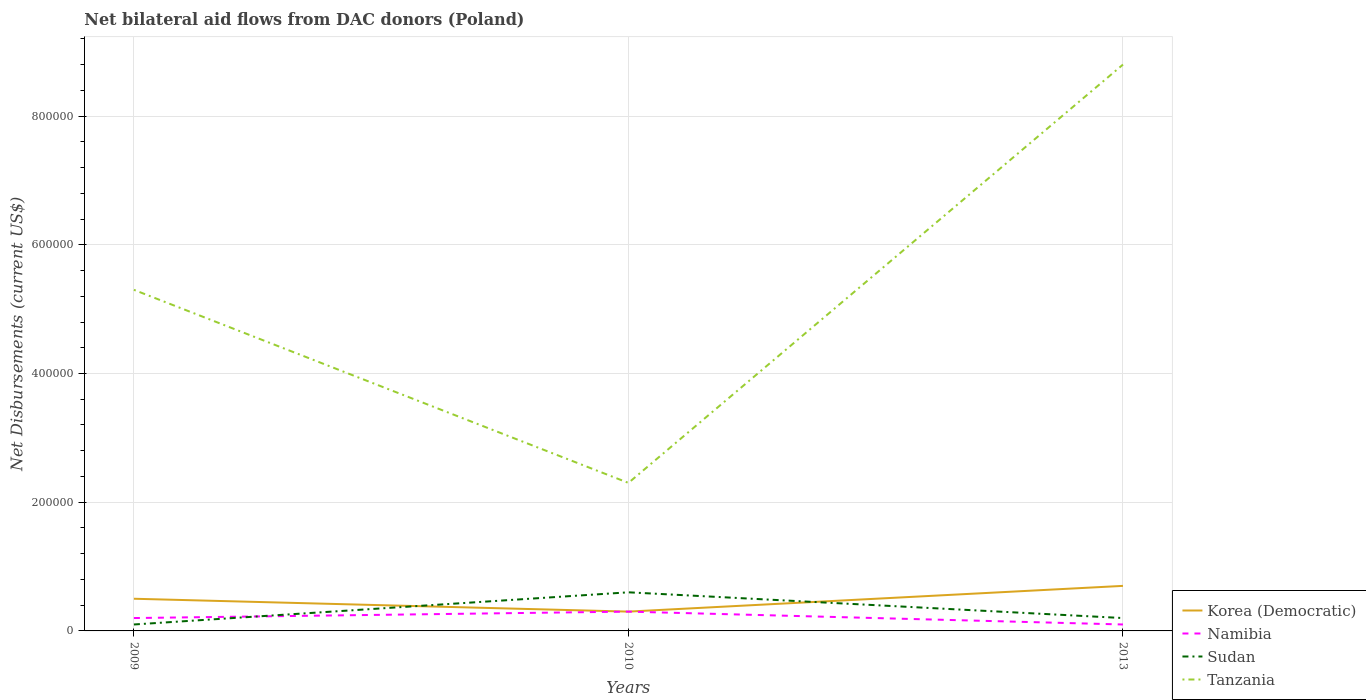Is the number of lines equal to the number of legend labels?
Offer a very short reply. Yes. Across all years, what is the maximum net bilateral aid flows in Korea (Democratic)?
Ensure brevity in your answer.  3.00e+04. What is the total net bilateral aid flows in Korea (Democratic) in the graph?
Offer a very short reply. 2.00e+04. What is the difference between the highest and the second highest net bilateral aid flows in Tanzania?
Your answer should be compact. 6.50e+05. What is the difference between the highest and the lowest net bilateral aid flows in Sudan?
Ensure brevity in your answer.  1. Is the net bilateral aid flows in Korea (Democratic) strictly greater than the net bilateral aid flows in Sudan over the years?
Make the answer very short. No. How many lines are there?
Provide a succinct answer. 4. How many years are there in the graph?
Your answer should be very brief. 3. Does the graph contain grids?
Your answer should be very brief. Yes. How many legend labels are there?
Offer a terse response. 4. What is the title of the graph?
Ensure brevity in your answer.  Net bilateral aid flows from DAC donors (Poland). What is the label or title of the Y-axis?
Ensure brevity in your answer.  Net Disbursements (current US$). What is the Net Disbursements (current US$) of Namibia in 2009?
Ensure brevity in your answer.  2.00e+04. What is the Net Disbursements (current US$) in Tanzania in 2009?
Offer a terse response. 5.30e+05. What is the Net Disbursements (current US$) of Korea (Democratic) in 2010?
Give a very brief answer. 3.00e+04. What is the Net Disbursements (current US$) in Namibia in 2010?
Your response must be concise. 3.00e+04. What is the Net Disbursements (current US$) in Tanzania in 2010?
Provide a short and direct response. 2.30e+05. What is the Net Disbursements (current US$) in Korea (Democratic) in 2013?
Your answer should be compact. 7.00e+04. What is the Net Disbursements (current US$) in Tanzania in 2013?
Provide a short and direct response. 8.80e+05. Across all years, what is the maximum Net Disbursements (current US$) of Korea (Democratic)?
Give a very brief answer. 7.00e+04. Across all years, what is the maximum Net Disbursements (current US$) in Tanzania?
Your answer should be compact. 8.80e+05. Across all years, what is the minimum Net Disbursements (current US$) in Namibia?
Your answer should be very brief. 10000. Across all years, what is the minimum Net Disbursements (current US$) of Tanzania?
Offer a terse response. 2.30e+05. What is the total Net Disbursements (current US$) in Namibia in the graph?
Offer a very short reply. 6.00e+04. What is the total Net Disbursements (current US$) in Sudan in the graph?
Offer a very short reply. 9.00e+04. What is the total Net Disbursements (current US$) in Tanzania in the graph?
Your answer should be compact. 1.64e+06. What is the difference between the Net Disbursements (current US$) of Korea (Democratic) in 2009 and that in 2010?
Your answer should be compact. 2.00e+04. What is the difference between the Net Disbursements (current US$) of Namibia in 2009 and that in 2010?
Your answer should be compact. -10000. What is the difference between the Net Disbursements (current US$) of Sudan in 2009 and that in 2010?
Your answer should be compact. -5.00e+04. What is the difference between the Net Disbursements (current US$) of Namibia in 2009 and that in 2013?
Your response must be concise. 10000. What is the difference between the Net Disbursements (current US$) of Sudan in 2009 and that in 2013?
Make the answer very short. -10000. What is the difference between the Net Disbursements (current US$) in Tanzania in 2009 and that in 2013?
Your answer should be compact. -3.50e+05. What is the difference between the Net Disbursements (current US$) in Korea (Democratic) in 2010 and that in 2013?
Give a very brief answer. -4.00e+04. What is the difference between the Net Disbursements (current US$) in Sudan in 2010 and that in 2013?
Ensure brevity in your answer.  4.00e+04. What is the difference between the Net Disbursements (current US$) of Tanzania in 2010 and that in 2013?
Provide a short and direct response. -6.50e+05. What is the difference between the Net Disbursements (current US$) of Korea (Democratic) in 2009 and the Net Disbursements (current US$) of Namibia in 2010?
Provide a short and direct response. 2.00e+04. What is the difference between the Net Disbursements (current US$) of Namibia in 2009 and the Net Disbursements (current US$) of Sudan in 2010?
Your answer should be compact. -4.00e+04. What is the difference between the Net Disbursements (current US$) in Sudan in 2009 and the Net Disbursements (current US$) in Tanzania in 2010?
Provide a succinct answer. -2.20e+05. What is the difference between the Net Disbursements (current US$) in Korea (Democratic) in 2009 and the Net Disbursements (current US$) in Tanzania in 2013?
Make the answer very short. -8.30e+05. What is the difference between the Net Disbursements (current US$) of Namibia in 2009 and the Net Disbursements (current US$) of Tanzania in 2013?
Ensure brevity in your answer.  -8.60e+05. What is the difference between the Net Disbursements (current US$) in Sudan in 2009 and the Net Disbursements (current US$) in Tanzania in 2013?
Your response must be concise. -8.70e+05. What is the difference between the Net Disbursements (current US$) in Korea (Democratic) in 2010 and the Net Disbursements (current US$) in Sudan in 2013?
Your answer should be very brief. 10000. What is the difference between the Net Disbursements (current US$) of Korea (Democratic) in 2010 and the Net Disbursements (current US$) of Tanzania in 2013?
Ensure brevity in your answer.  -8.50e+05. What is the difference between the Net Disbursements (current US$) of Namibia in 2010 and the Net Disbursements (current US$) of Tanzania in 2013?
Your answer should be very brief. -8.50e+05. What is the difference between the Net Disbursements (current US$) in Sudan in 2010 and the Net Disbursements (current US$) in Tanzania in 2013?
Your response must be concise. -8.20e+05. What is the average Net Disbursements (current US$) in Korea (Democratic) per year?
Your response must be concise. 5.00e+04. What is the average Net Disbursements (current US$) of Tanzania per year?
Your response must be concise. 5.47e+05. In the year 2009, what is the difference between the Net Disbursements (current US$) in Korea (Democratic) and Net Disbursements (current US$) in Tanzania?
Give a very brief answer. -4.80e+05. In the year 2009, what is the difference between the Net Disbursements (current US$) in Namibia and Net Disbursements (current US$) in Sudan?
Your answer should be very brief. 10000. In the year 2009, what is the difference between the Net Disbursements (current US$) in Namibia and Net Disbursements (current US$) in Tanzania?
Ensure brevity in your answer.  -5.10e+05. In the year 2009, what is the difference between the Net Disbursements (current US$) in Sudan and Net Disbursements (current US$) in Tanzania?
Keep it short and to the point. -5.20e+05. In the year 2010, what is the difference between the Net Disbursements (current US$) in Korea (Democratic) and Net Disbursements (current US$) in Namibia?
Your response must be concise. 0. In the year 2010, what is the difference between the Net Disbursements (current US$) of Namibia and Net Disbursements (current US$) of Tanzania?
Provide a succinct answer. -2.00e+05. In the year 2010, what is the difference between the Net Disbursements (current US$) of Sudan and Net Disbursements (current US$) of Tanzania?
Your answer should be very brief. -1.70e+05. In the year 2013, what is the difference between the Net Disbursements (current US$) of Korea (Democratic) and Net Disbursements (current US$) of Sudan?
Make the answer very short. 5.00e+04. In the year 2013, what is the difference between the Net Disbursements (current US$) in Korea (Democratic) and Net Disbursements (current US$) in Tanzania?
Ensure brevity in your answer.  -8.10e+05. In the year 2013, what is the difference between the Net Disbursements (current US$) of Namibia and Net Disbursements (current US$) of Tanzania?
Give a very brief answer. -8.70e+05. In the year 2013, what is the difference between the Net Disbursements (current US$) of Sudan and Net Disbursements (current US$) of Tanzania?
Keep it short and to the point. -8.60e+05. What is the ratio of the Net Disbursements (current US$) in Korea (Democratic) in 2009 to that in 2010?
Provide a succinct answer. 1.67. What is the ratio of the Net Disbursements (current US$) of Namibia in 2009 to that in 2010?
Give a very brief answer. 0.67. What is the ratio of the Net Disbursements (current US$) in Sudan in 2009 to that in 2010?
Provide a short and direct response. 0.17. What is the ratio of the Net Disbursements (current US$) of Tanzania in 2009 to that in 2010?
Offer a terse response. 2.3. What is the ratio of the Net Disbursements (current US$) of Korea (Democratic) in 2009 to that in 2013?
Provide a short and direct response. 0.71. What is the ratio of the Net Disbursements (current US$) in Namibia in 2009 to that in 2013?
Provide a short and direct response. 2. What is the ratio of the Net Disbursements (current US$) of Sudan in 2009 to that in 2013?
Your answer should be compact. 0.5. What is the ratio of the Net Disbursements (current US$) in Tanzania in 2009 to that in 2013?
Your response must be concise. 0.6. What is the ratio of the Net Disbursements (current US$) of Korea (Democratic) in 2010 to that in 2013?
Provide a succinct answer. 0.43. What is the ratio of the Net Disbursements (current US$) of Tanzania in 2010 to that in 2013?
Keep it short and to the point. 0.26. What is the difference between the highest and the second highest Net Disbursements (current US$) in Korea (Democratic)?
Your answer should be compact. 2.00e+04. What is the difference between the highest and the second highest Net Disbursements (current US$) in Namibia?
Ensure brevity in your answer.  10000. What is the difference between the highest and the second highest Net Disbursements (current US$) of Sudan?
Offer a terse response. 4.00e+04. What is the difference between the highest and the second highest Net Disbursements (current US$) of Tanzania?
Give a very brief answer. 3.50e+05. What is the difference between the highest and the lowest Net Disbursements (current US$) of Namibia?
Provide a succinct answer. 2.00e+04. What is the difference between the highest and the lowest Net Disbursements (current US$) of Sudan?
Your response must be concise. 5.00e+04. What is the difference between the highest and the lowest Net Disbursements (current US$) of Tanzania?
Offer a terse response. 6.50e+05. 